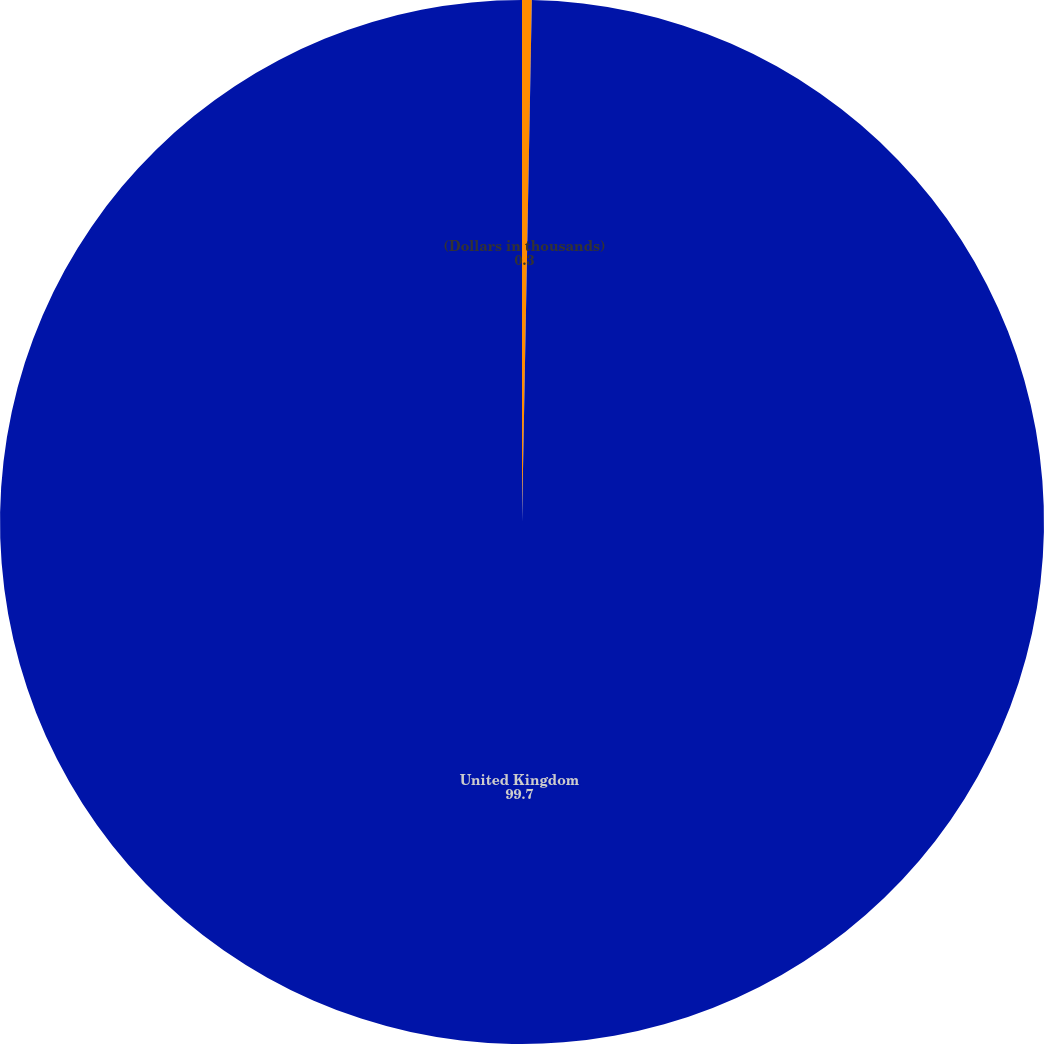Convert chart to OTSL. <chart><loc_0><loc_0><loc_500><loc_500><pie_chart><fcel>(Dollars in thousands)<fcel>United Kingdom<nl><fcel>0.3%<fcel>99.7%<nl></chart> 